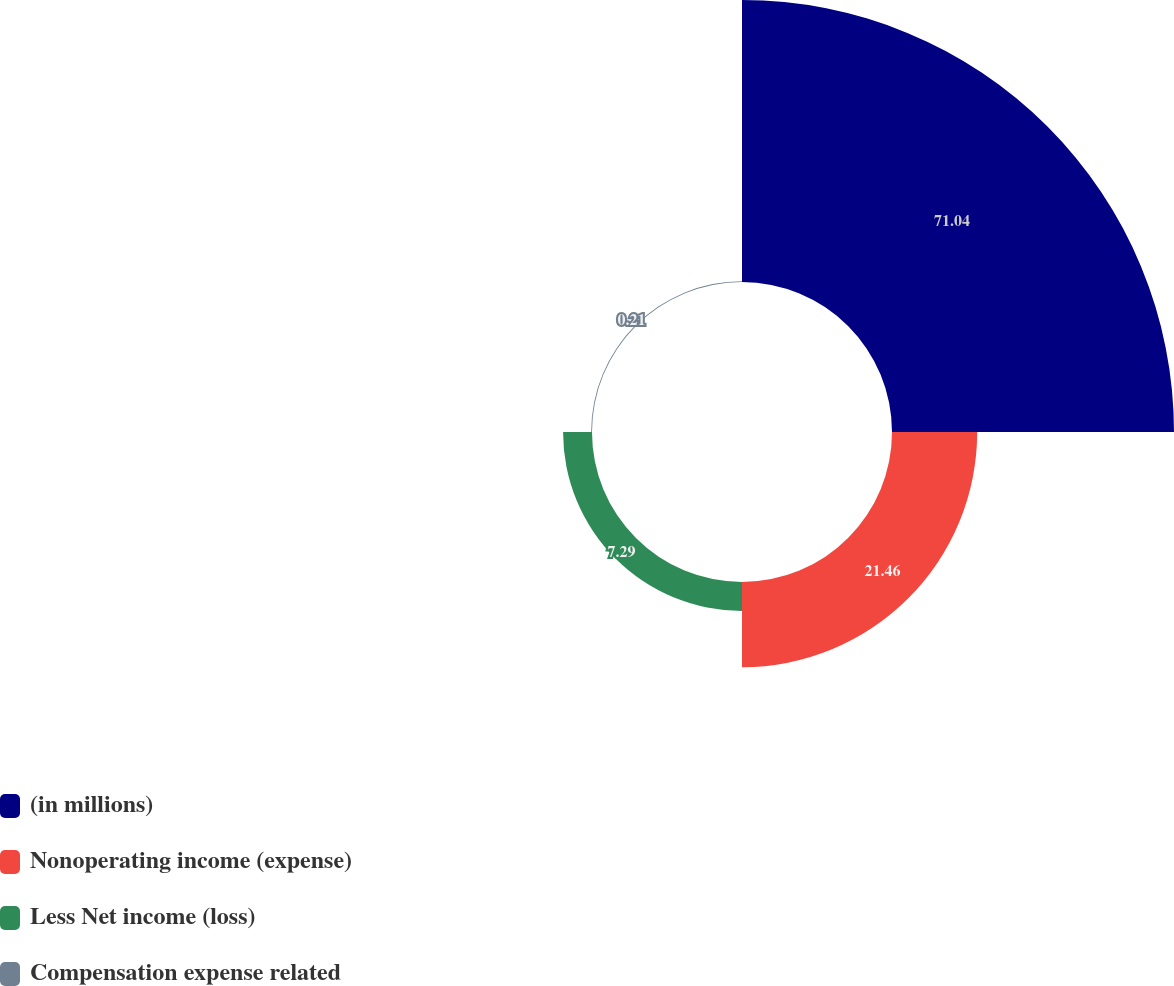<chart> <loc_0><loc_0><loc_500><loc_500><pie_chart><fcel>(in millions)<fcel>Nonoperating income (expense)<fcel>Less Net income (loss)<fcel>Compensation expense related<nl><fcel>71.04%<fcel>21.46%<fcel>7.29%<fcel>0.21%<nl></chart> 